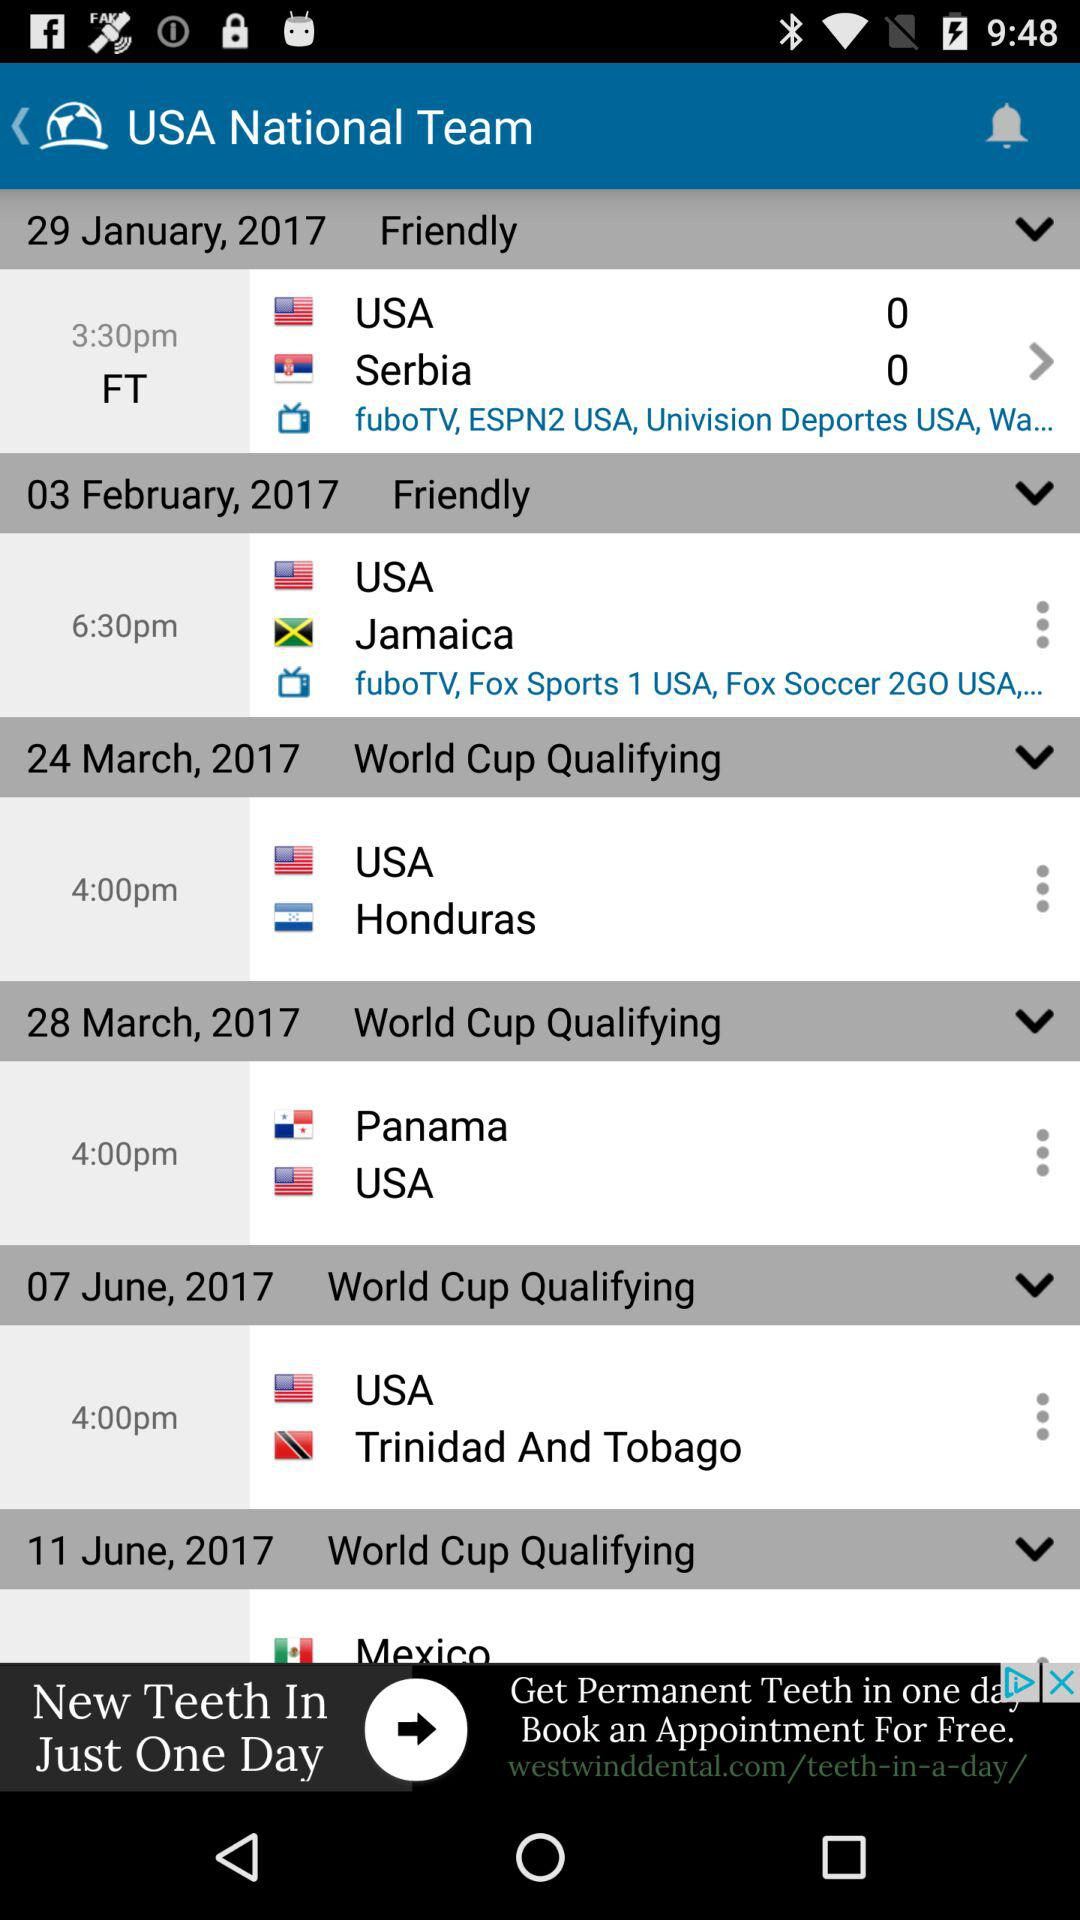How many matches are upcoming?
Answer the question using a single word or phrase. 6 